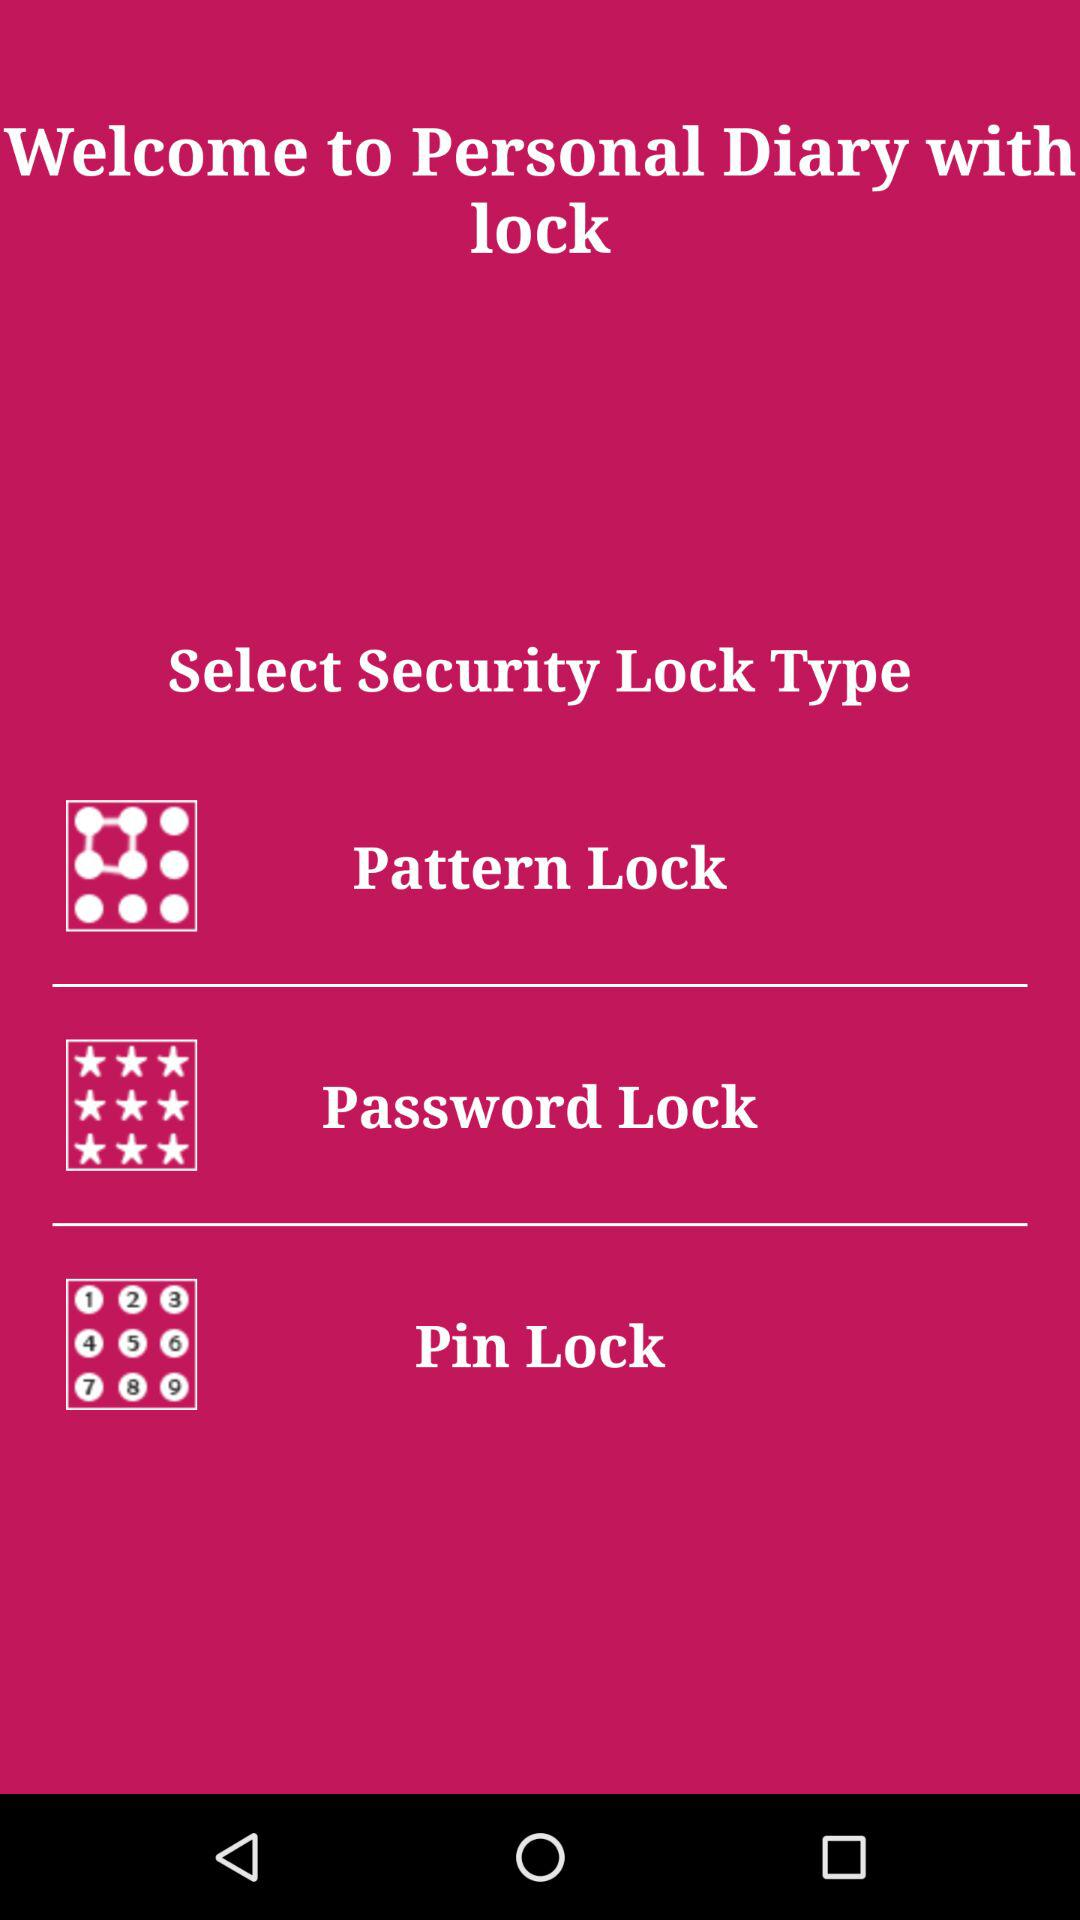How many security lock types are available?
Answer the question using a single word or phrase. 3 